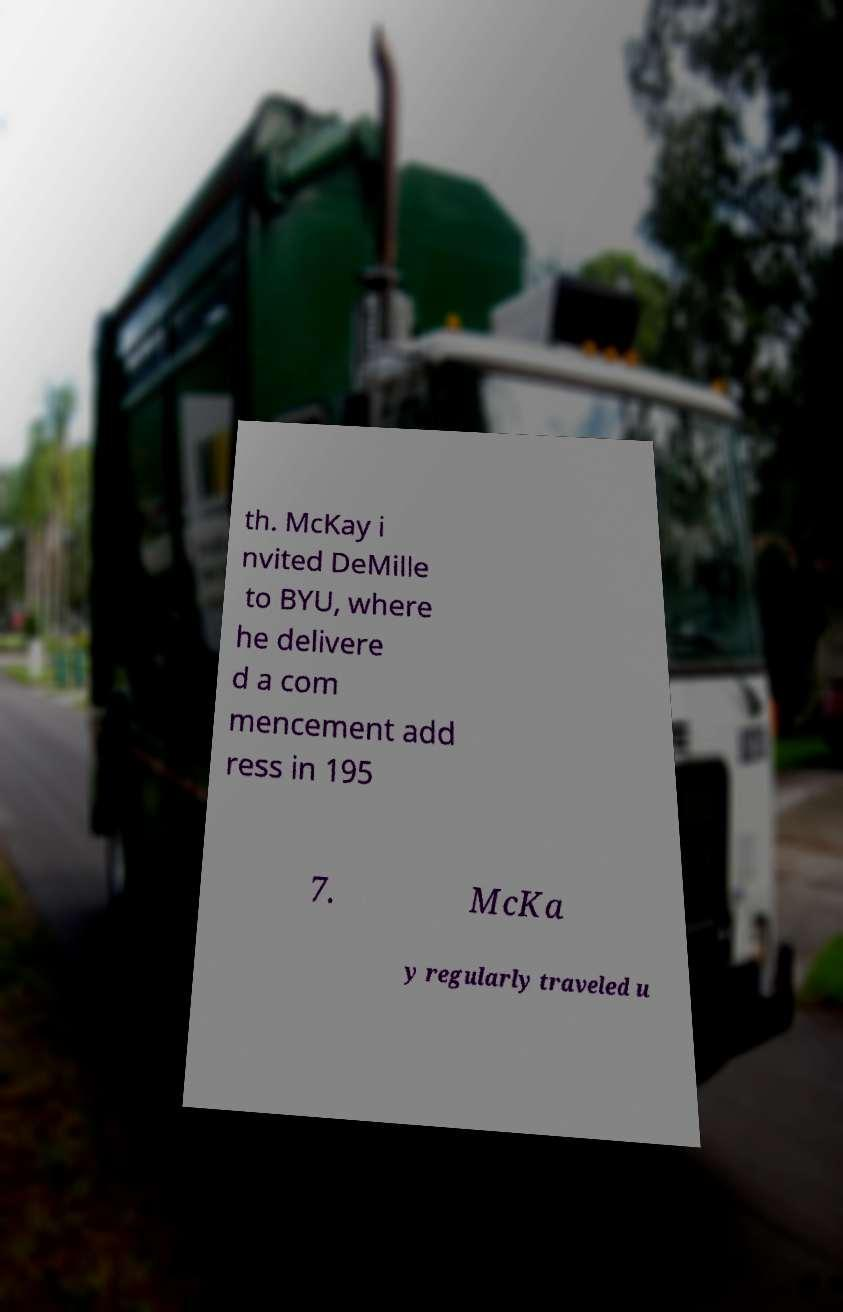There's text embedded in this image that I need extracted. Can you transcribe it verbatim? th. McKay i nvited DeMille to BYU, where he delivere d a com mencement add ress in 195 7. McKa y regularly traveled u 